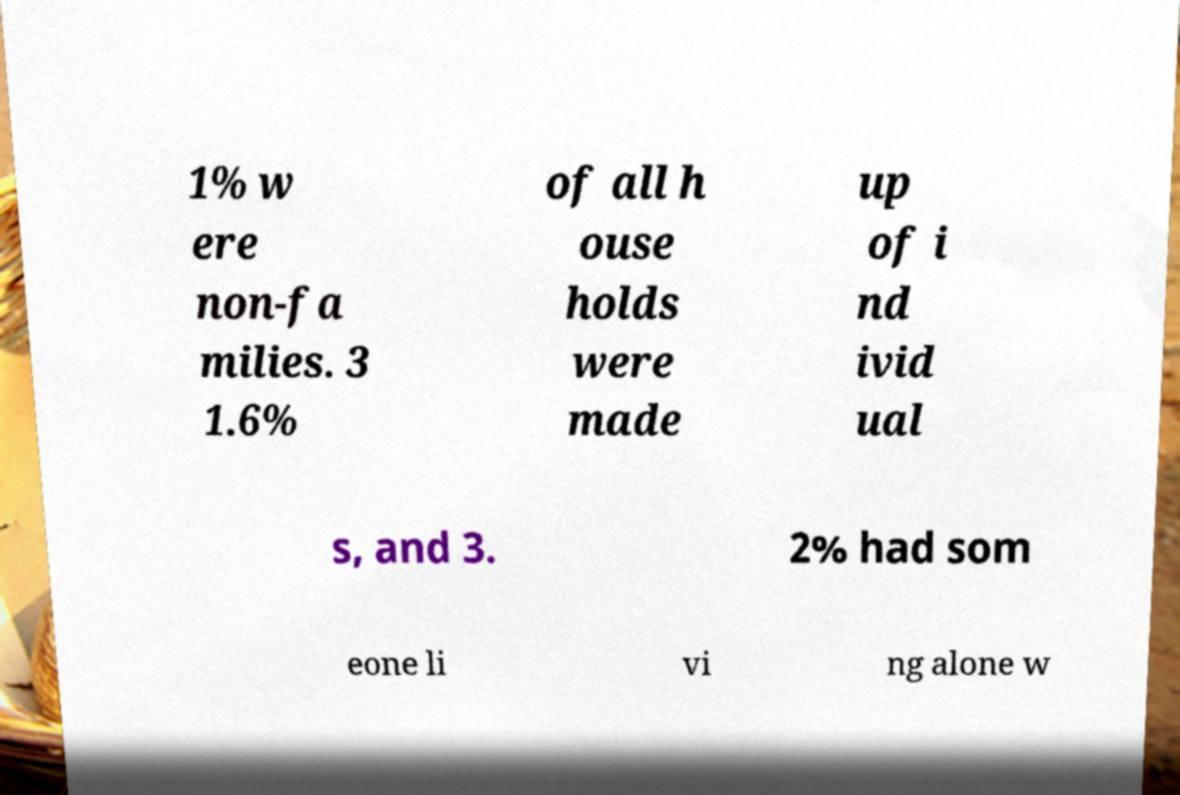For documentation purposes, I need the text within this image transcribed. Could you provide that? 1% w ere non-fa milies. 3 1.6% of all h ouse holds were made up of i nd ivid ual s, and 3. 2% had som eone li vi ng alone w 